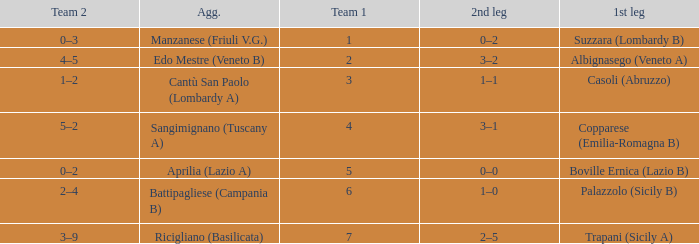What is the mean team 1 when the 1st leg is Albignasego (Veneto A)? 2.0. I'm looking to parse the entire table for insights. Could you assist me with that? {'header': ['Team 2', 'Agg.', 'Team 1', '2nd leg', '1st leg'], 'rows': [['0–3', 'Manzanese (Friuli V.G.)', '1', '0–2', 'Suzzara (Lombardy B)'], ['4–5', 'Edo Mestre (Veneto B)', '2', '3–2', 'Albignasego (Veneto A)'], ['1–2', 'Cantù San Paolo (Lombardy A)', '3', '1–1', 'Casoli (Abruzzo)'], ['5–2', 'Sangimignano (Tuscany A)', '4', '3–1', 'Copparese (Emilia-Romagna B)'], ['0–2', 'Aprilia (Lazio A)', '5', '0–0', 'Boville Ernica (Lazio B)'], ['2–4', 'Battipagliese (Campania B)', '6', '1–0', 'Palazzolo (Sicily B)'], ['3–9', 'Ricigliano (Basilicata)', '7', '2–5', 'Trapani (Sicily A)']]} 